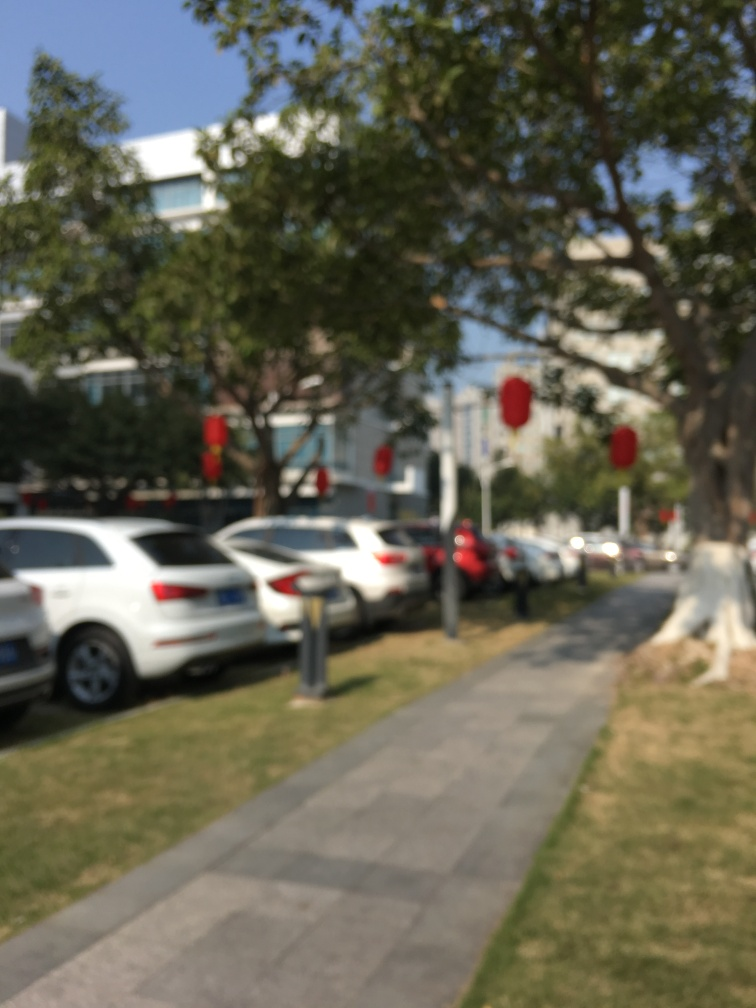Is there anything in this image that could help determine the location? The presence of the red lantern-like objects could hint at a location where such decorations are common, perhaps during a traditional festival or holiday. However, due to the blur, it is not possible to determine distinctive architectural styles or signage that might provide more precise clues about the location.  Are there any notable elements that could be useful if this image were clearer? If the image were in focus, we might be able to identify specific vehicle models, license plates, street signs, or other environmental text that could give us clues about the location, time, and even cultural or seasonal context of the photograph. 